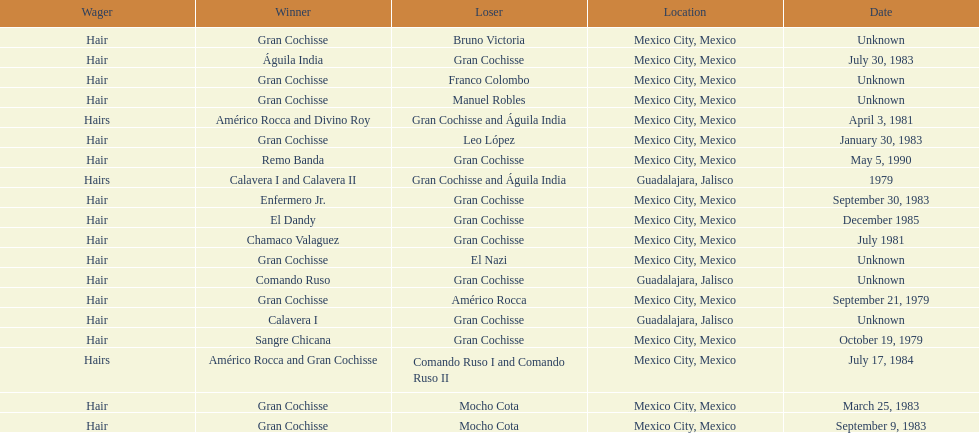When was gran chochisse first match that had a full date on record? September 21, 1979. 